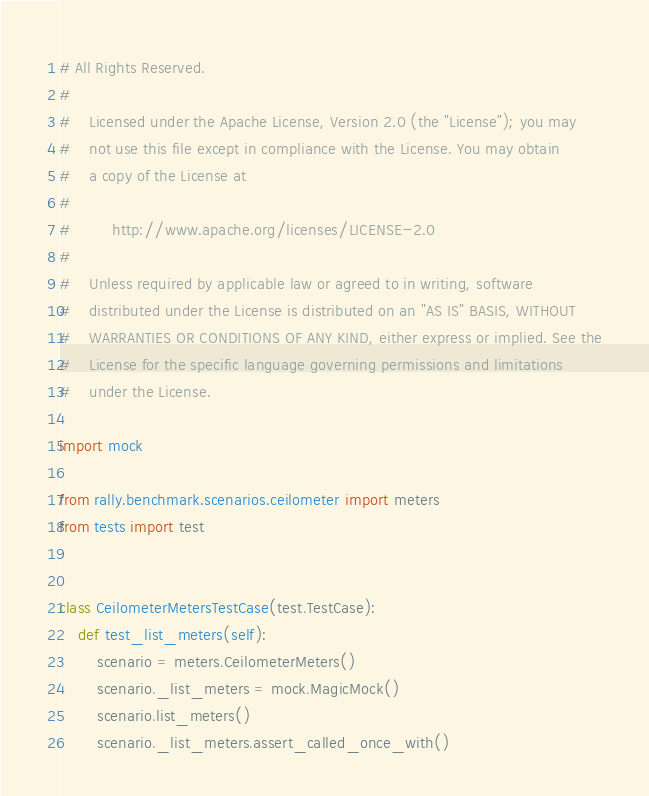Convert code to text. <code><loc_0><loc_0><loc_500><loc_500><_Python_># All Rights Reserved.
#
#    Licensed under the Apache License, Version 2.0 (the "License"); you may
#    not use this file except in compliance with the License. You may obtain
#    a copy of the License at
#
#         http://www.apache.org/licenses/LICENSE-2.0
#
#    Unless required by applicable law or agreed to in writing, software
#    distributed under the License is distributed on an "AS IS" BASIS, WITHOUT
#    WARRANTIES OR CONDITIONS OF ANY KIND, either express or implied. See the
#    License for the specific language governing permissions and limitations
#    under the License.

import mock

from rally.benchmark.scenarios.ceilometer import meters
from tests import test


class CeilometerMetersTestCase(test.TestCase):
    def test_list_meters(self):
        scenario = meters.CeilometerMeters()
        scenario._list_meters = mock.MagicMock()
        scenario.list_meters()
        scenario._list_meters.assert_called_once_with()
</code> 